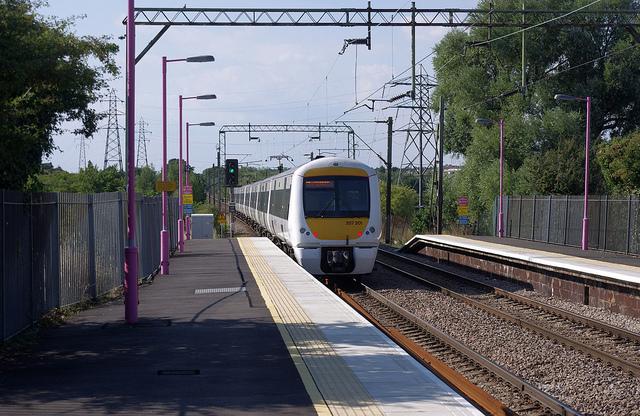How many tracks are there?
Give a very brief answer. 2. What color are the lights in front of the train?
Answer briefly. Red. Are their passengers waiting for the train?
Be succinct. No. 